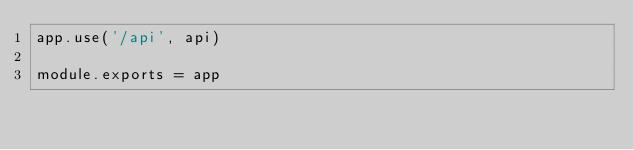<code> <loc_0><loc_0><loc_500><loc_500><_JavaScript_>app.use('/api', api)

module.exports = app
</code> 